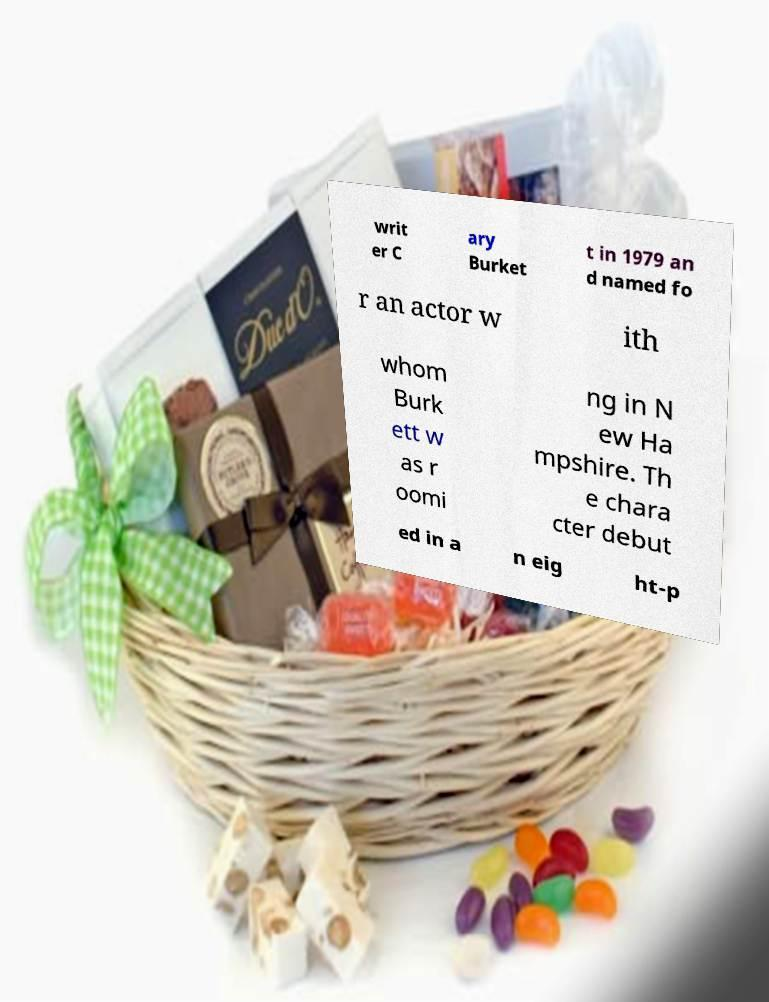Please read and relay the text visible in this image. What does it say? writ er C ary Burket t in 1979 an d named fo r an actor w ith whom Burk ett w as r oomi ng in N ew Ha mpshire. Th e chara cter debut ed in a n eig ht-p 